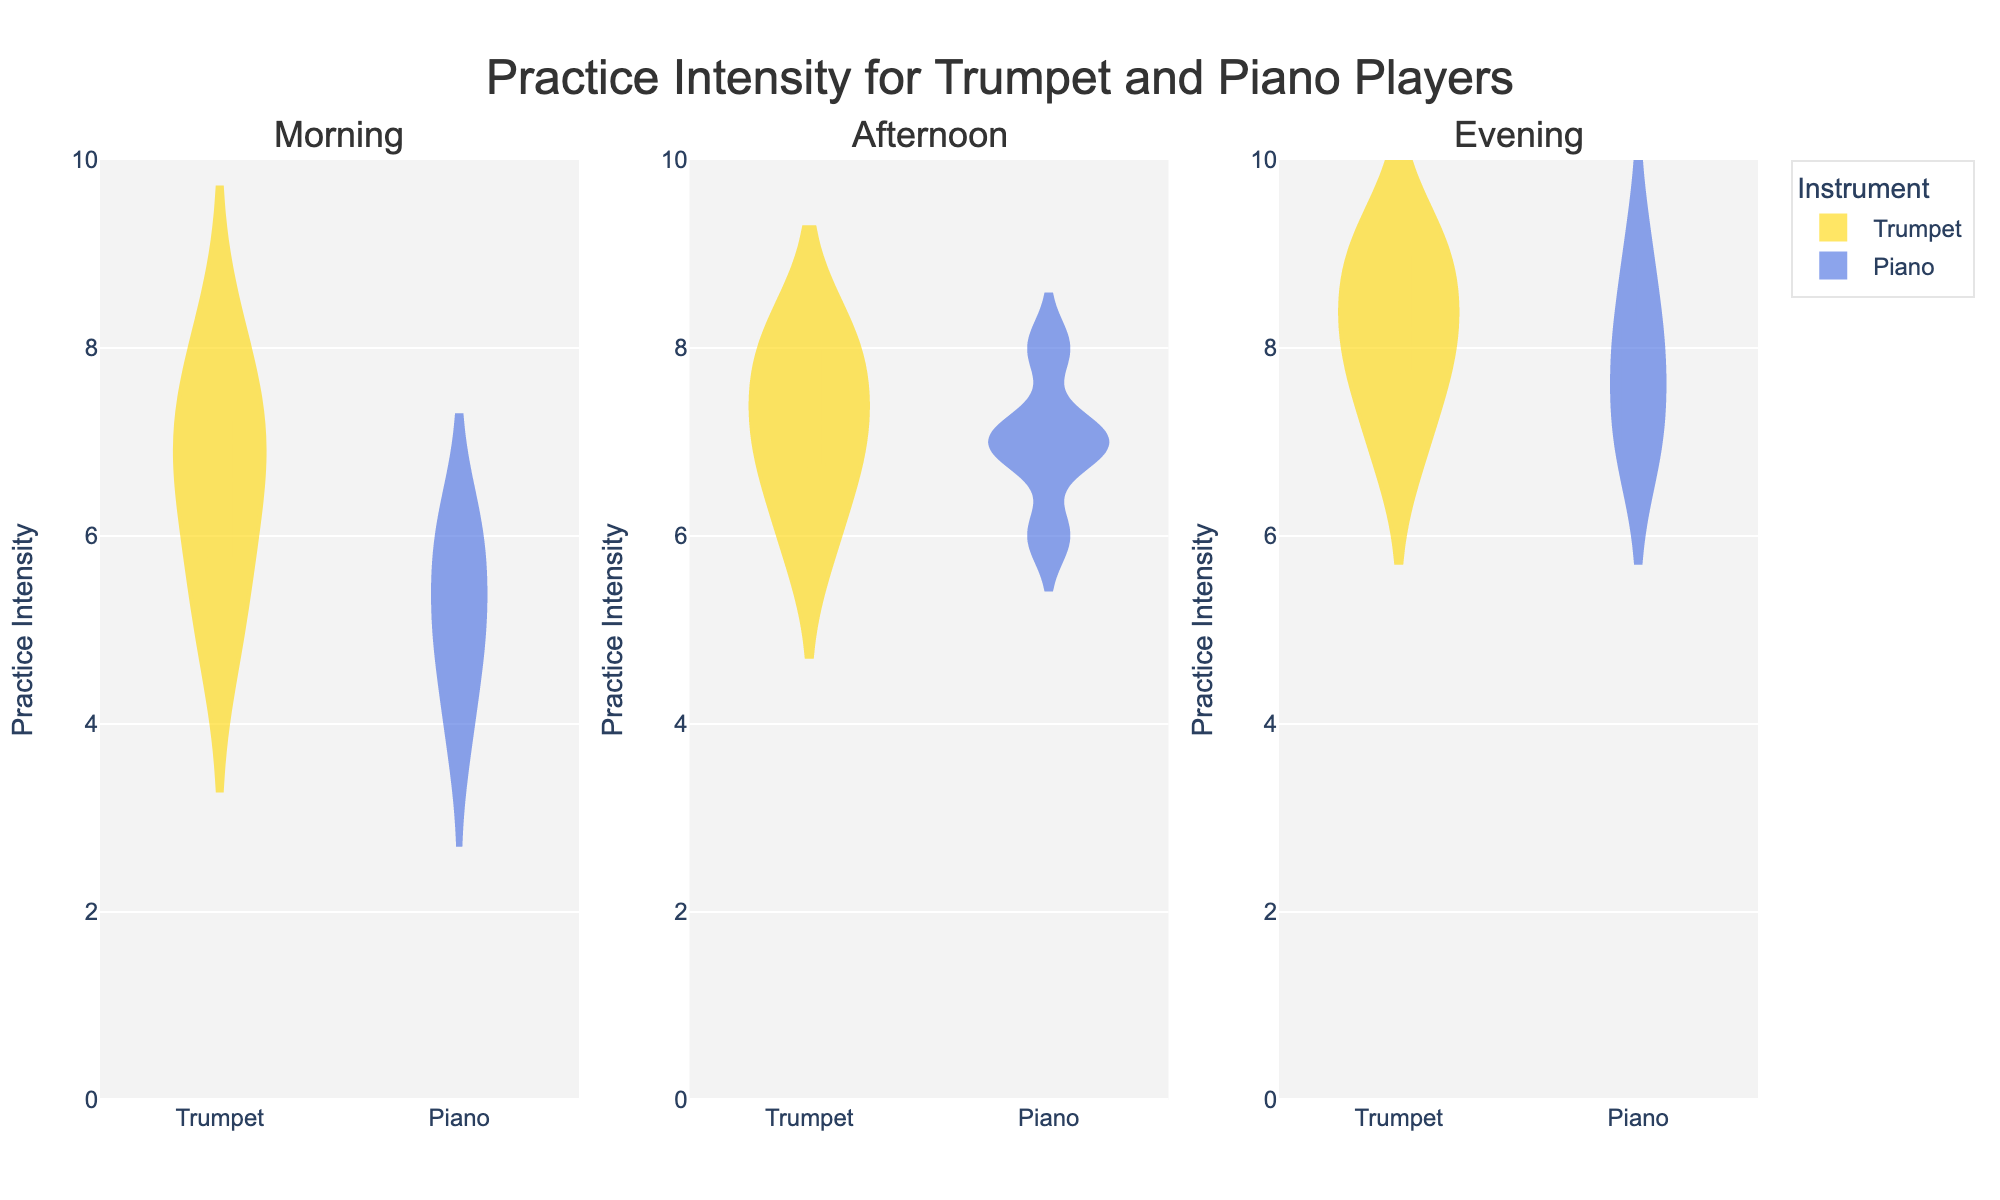What is the title of the figure? The title is typically located at the top of the figure and it provides a succinct description of what the figure represents.
Answer: Practice Intensity for Trumpet and Piano Players Which instrument has a higher median practice intensity in the evening? In the evening subplot, compare the horizontal lines in the center of the violins for both instruments. The median is indicated by this line.
Answer: Trumpet How does the practice intensity of the trumpet players vary between morning and evening? Compare the spread and central tendency of the violin plots for the trumpet players in the morning and evening subplots. Look at the quartiles and median.
Answer: More intense and higher in the evening What time of day has the widest range of practice intensity for piano players? Compare the length of the violin plots for piano players across the three subplots. The widest range will have the elongated vertical spread.
Answer: Afternoon What is the mean practice intensity for trumpet players in the afternoon? Find the mean line in the trumpet players' violin plot in the afternoon subplot. It's typically shown by a dashed line or a mark through the violin plot.
Answer: 7.2 How does the evening practice intensity for piano players compare to morning practice intensity for the same instrument? Compare the spread, median, and overall appearance of the violin plots for piano players in the morning and evening subplots. Look at the position of the boxes within each violin plot.
Answer: Higher and more intense in the evening What is the color used to represent the violin plots for trumpet players? Identify the color of the violin plots labeled 'Trumpet' in any of the subplots.
Answer: Gold Which time of day shows the least variation in practice intensity for trumpet players? The least variation will be represented by the shortest vertical span of the violin plot for trumpet players. Compare across the three subplots.
Answer: Morning Which instrument shows more consistent practice intensity in the morning? The more consistent practice intensity will show a narrower violin plot with less spread of the data points. Compare the shapes of the violin plots for both instruments in the morning subplot.
Answer: Piano How many data points are there for trumpet players in the afternoon? Count the number of data points (individual y-values) for trumpet players in the afternoon subplot.
Answer: 5 